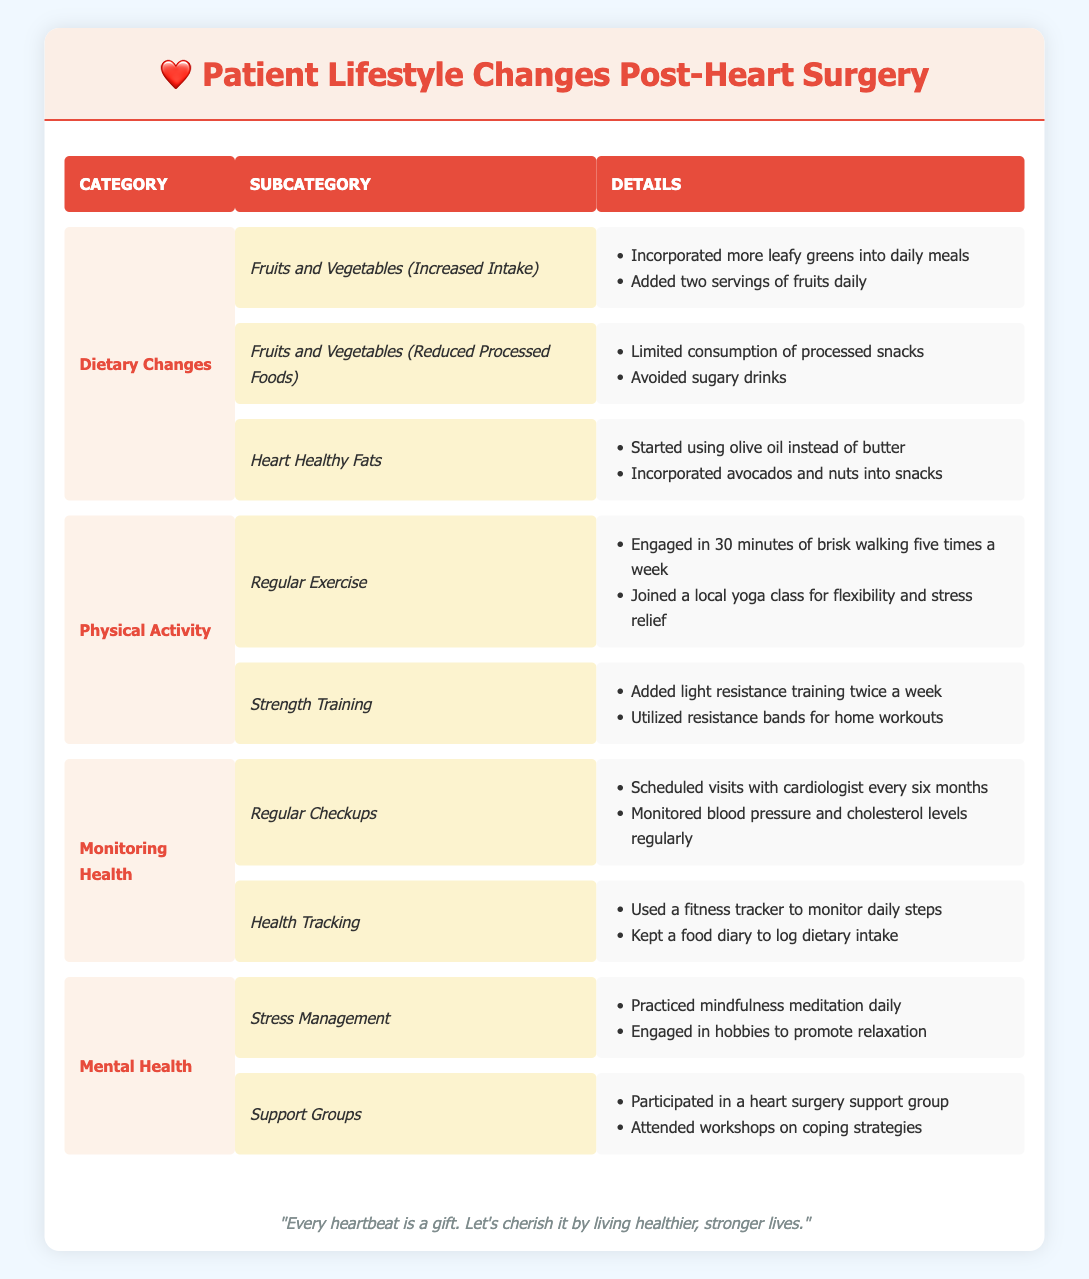What dietary changes did patients make in terms of fruit and vegetable intake? The table categorizes dietary changes into "Increased Intake" and "Reduced Processed Foods" under "Fruits and Vegetables." The details list specific changes: incorporating more leafy greens and adding two servings of fruits daily for increased intake, and limiting processed snacks and avoiding sugary drinks for reduced processed foods.
Answer: Increased intake and reduced processed foods How many changes were made in the 'Monitoring Health' category? There are two subcategories under "Monitoring Health": "Regular Checkups" and "Health Tracking." Each subcategory has two details listed: scheduled visits with a cardiologist and monitoring blood pressure in "Regular Checkups," and using a fitness tracker and keeping a food diary in "Health Tracking." Thus, there are 4 distinct details for the "Monitoring Health" category.
Answer: Four changes Is there a mention of any specific type of exercise included in the 'Regular Exercise' category? Yes, the "Regular Exercise" subcategory under "Physical Activity" lists engaging in 30 minutes of brisk walking and joining a local yoga class as specific types of exercises.
Answer: Yes What is the total number of details listed across all subcategories under 'Mental Health'? The "Mental Health" category has two subcategories: "Stress Management" and "Support Groups," with each containing two details. Therefore, the total details are 2 (stress management) + 2 (support groups) = 4.
Answer: Four details Did patients utilize a fitness tracker as part of their lifestyle changes? Yes, the detail under "Health Tracking" specifies that patients used a fitness tracker to monitor daily steps, indicating its inclusion in lifestyle changes post-surgery.
Answer: Yes In which category did patients incorporate healthy fats, and what were the specific changes made? The category "Dietary Changes" includes "Heart Healthy Fats." Specific changes are listed: starting to use olive oil instead of butter and incorporating avocados and nuts into snacks.
Answer: Dietary Changes, using olive oil and incorporating avocados and nuts What type of training is included under 'Strength Training', and how often do patients engage in it? The "Strength Training" subcategory mentions light resistance training added twice a week and utilizing resistance bands for home workouts, indicating the frequency and type of training.
Answer: Light resistance training twice a week What are the two specific activities included in the 'Support Groups' category? Under the "Support Groups" subcategory in the "Mental Health" category, two specific activities are mentioned: participating in a heart surgery support group and attending workshops on coping strategies.
Answer: Participating in a support group and attending coping strategy workshops How often are patients recommended to have cardiology checkups according to the table? The "Regular Checkups" subcategory states that patients should schedule visits with a cardiologist every six months, which is the frequency mentioned in the table.
Answer: Every six months 